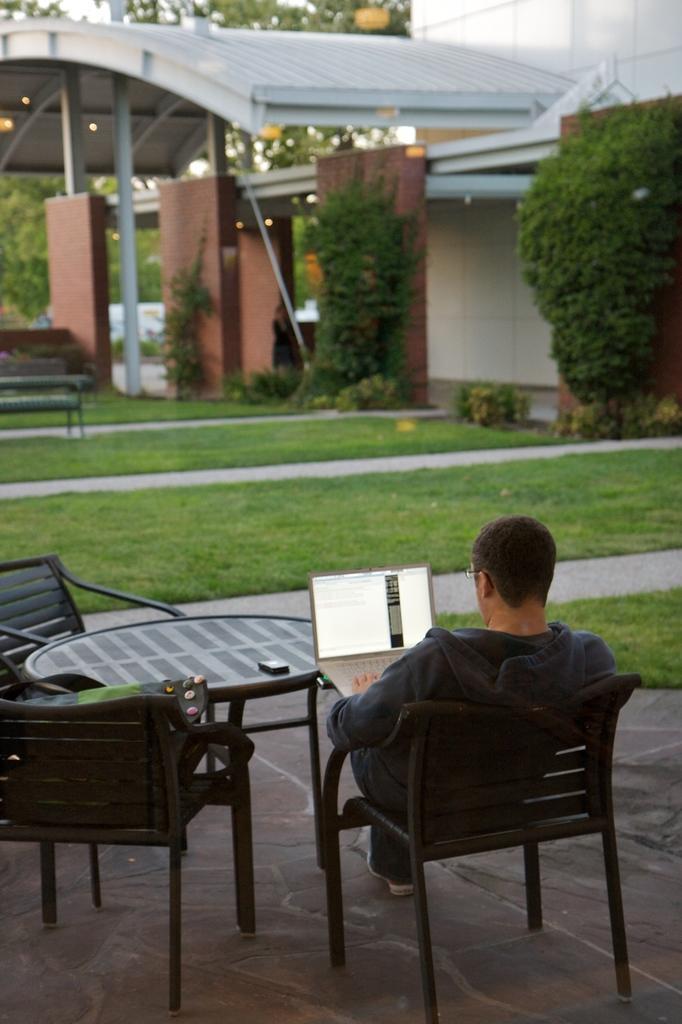Describe this image in one or two sentences. In this image, human is sat on the black chair. We can see chairs and table. Some item is placed on the table and chair. Here human is holding a laptop. We can see floor, grass here. And the background, we can see bench, planter, wall, pillar and shed and house. 